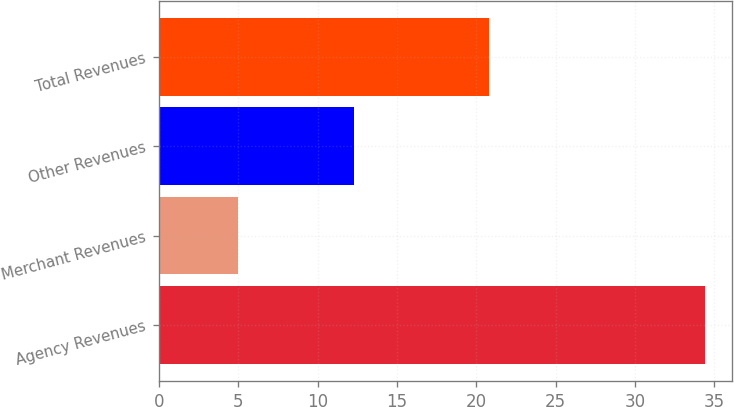<chart> <loc_0><loc_0><loc_500><loc_500><bar_chart><fcel>Agency Revenues<fcel>Merchant Revenues<fcel>Other Revenues<fcel>Total Revenues<nl><fcel>34.4<fcel>5<fcel>12.3<fcel>20.8<nl></chart> 